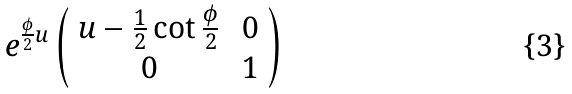Convert formula to latex. <formula><loc_0><loc_0><loc_500><loc_500>e ^ { \frac { \phi } { 2 } u } \left ( \begin{array} { c c } u - \frac { 1 } { 2 } \cot \frac { \phi } { 2 } & \, 0 \\ 0 & \, 1 \end{array} \right )</formula> 